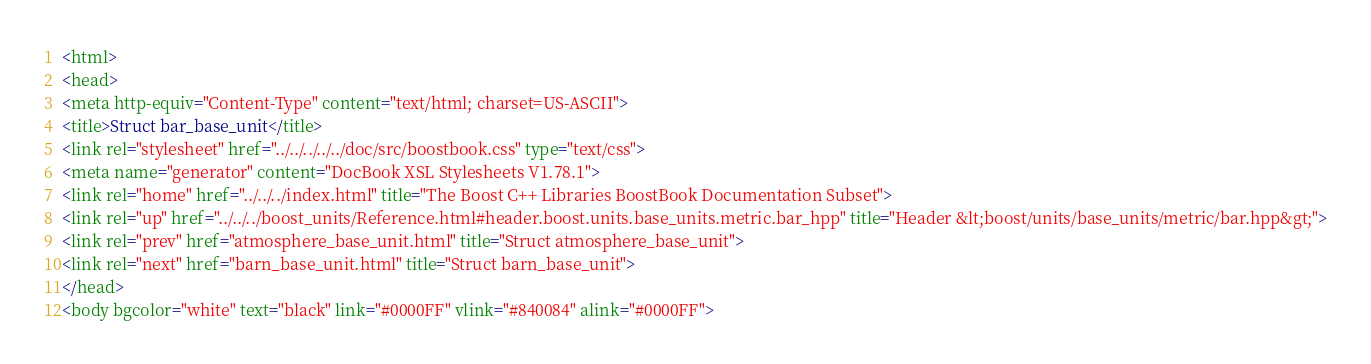<code> <loc_0><loc_0><loc_500><loc_500><_HTML_><html>
<head>
<meta http-equiv="Content-Type" content="text/html; charset=US-ASCII">
<title>Struct bar_base_unit</title>
<link rel="stylesheet" href="../../../../../doc/src/boostbook.css" type="text/css">
<meta name="generator" content="DocBook XSL Stylesheets V1.78.1">
<link rel="home" href="../../../index.html" title="The Boost C++ Libraries BoostBook Documentation Subset">
<link rel="up" href="../../../boost_units/Reference.html#header.boost.units.base_units.metric.bar_hpp" title="Header &lt;boost/units/base_units/metric/bar.hpp&gt;">
<link rel="prev" href="atmosphere_base_unit.html" title="Struct atmosphere_base_unit">
<link rel="next" href="barn_base_unit.html" title="Struct barn_base_unit">
</head>
<body bgcolor="white" text="black" link="#0000FF" vlink="#840084" alink="#0000FF"></code> 